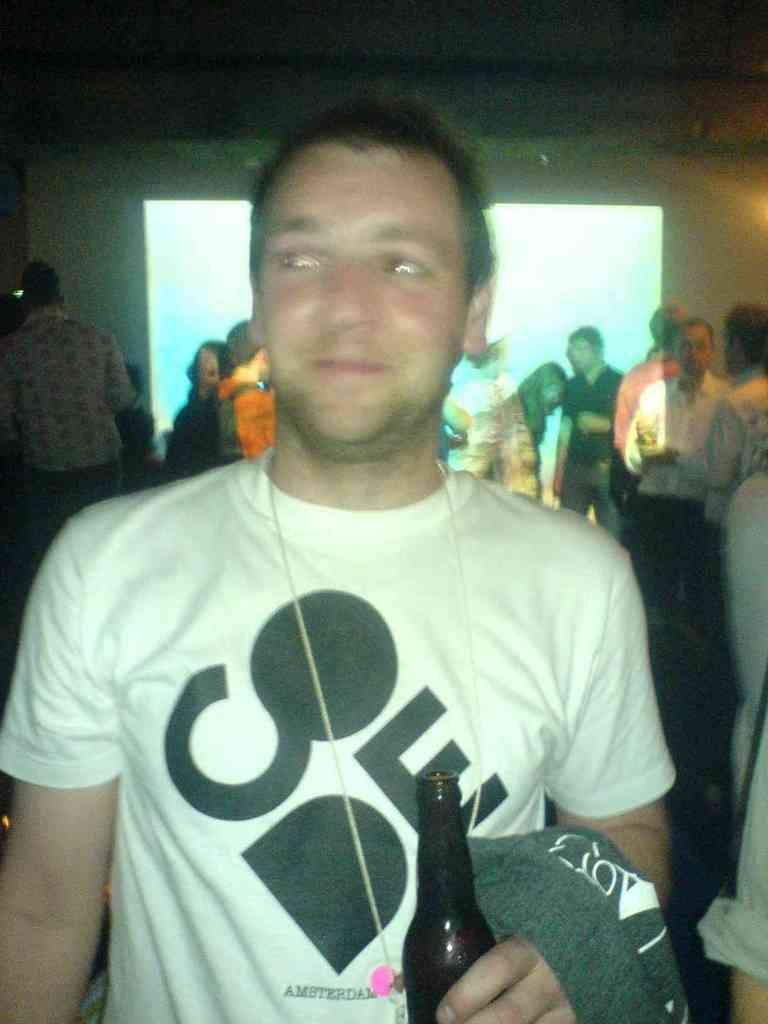Who is present in the image? There is a man in the image. What is the man doing in the image? The man is smiling and holding a bottle in his hand. What can be seen in the background of the image? There are people, a banner, and a screen in the background of the image. What type of duck can be seen swimming near the coast in the image? There is no duck or coast present in the image; it features a man smiling and holding a bottle, with people, a banner, and a screen in the background. 